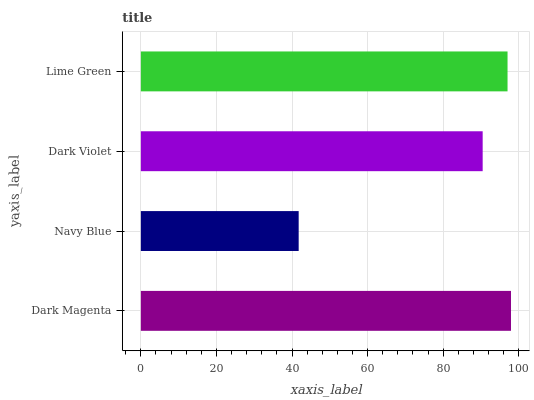Is Navy Blue the minimum?
Answer yes or no. Yes. Is Dark Magenta the maximum?
Answer yes or no. Yes. Is Dark Violet the minimum?
Answer yes or no. No. Is Dark Violet the maximum?
Answer yes or no. No. Is Dark Violet greater than Navy Blue?
Answer yes or no. Yes. Is Navy Blue less than Dark Violet?
Answer yes or no. Yes. Is Navy Blue greater than Dark Violet?
Answer yes or no. No. Is Dark Violet less than Navy Blue?
Answer yes or no. No. Is Lime Green the high median?
Answer yes or no. Yes. Is Dark Violet the low median?
Answer yes or no. Yes. Is Dark Magenta the high median?
Answer yes or no. No. Is Dark Magenta the low median?
Answer yes or no. No. 